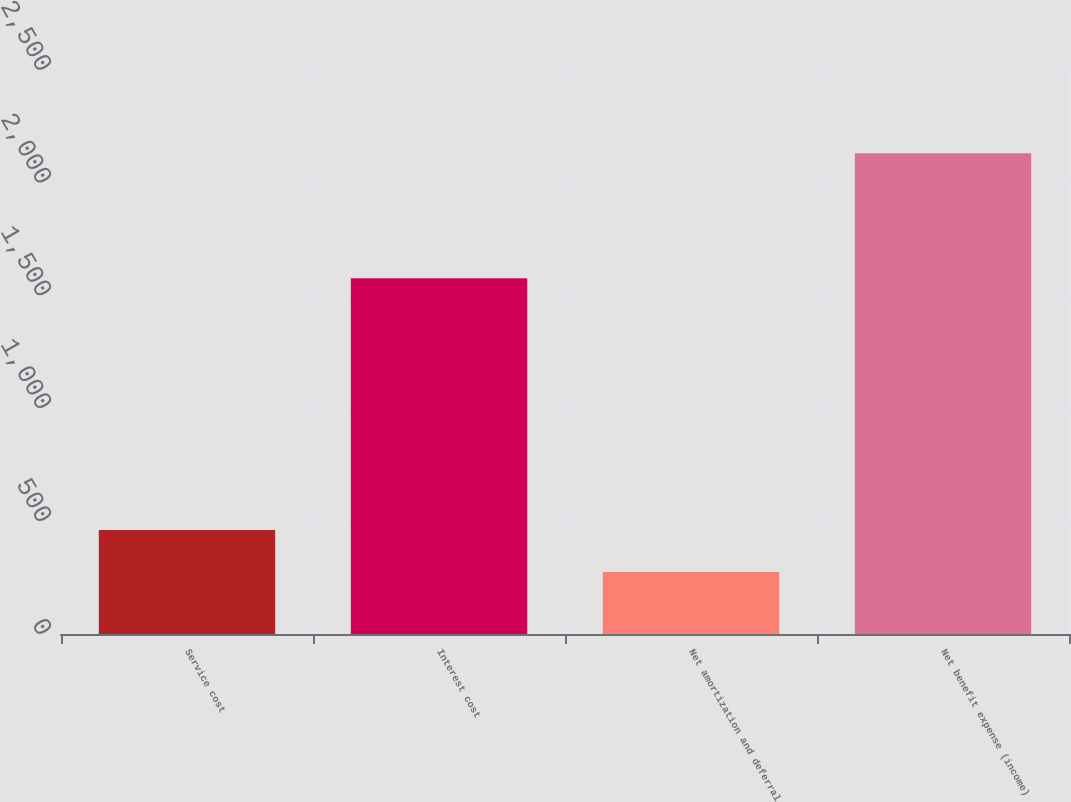Convert chart. <chart><loc_0><loc_0><loc_500><loc_500><bar_chart><fcel>Service cost<fcel>Interest cost<fcel>Net amortization and deferral<fcel>Net benefit expense (income)<nl><fcel>460.6<fcel>1577<fcel>275<fcel>2131<nl></chart> 